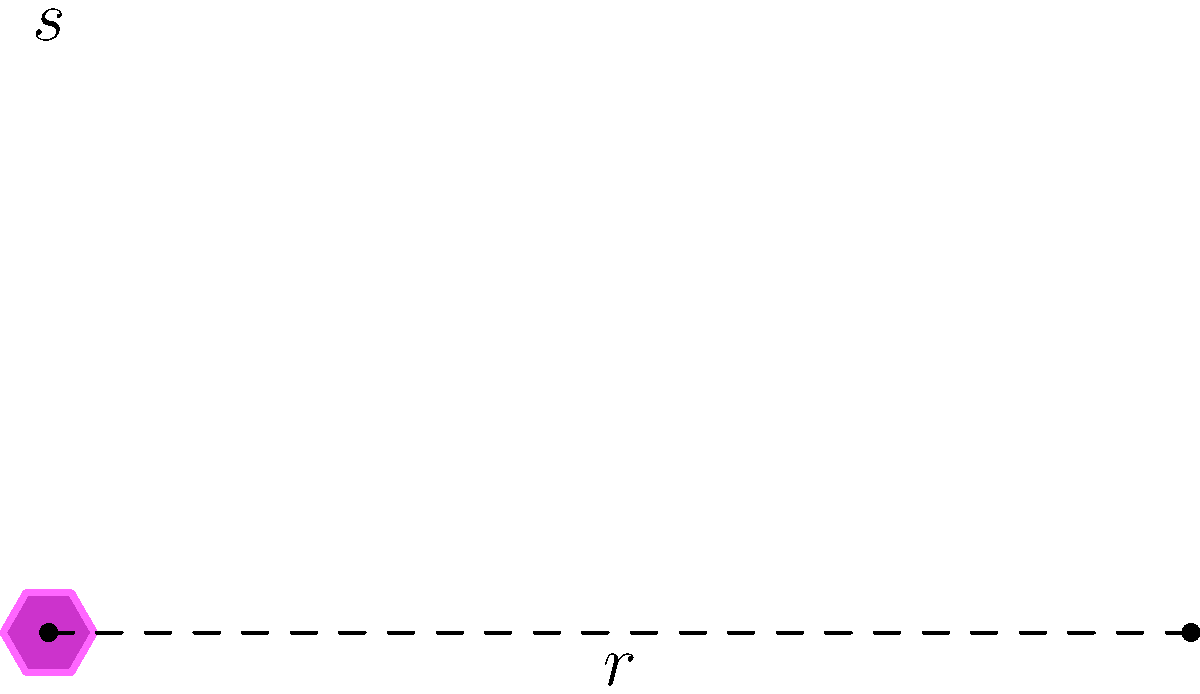At the Starlight Arcade, you're setting up a retro-themed Jem and the Holograms game inside a hexagonal cabinet. The cabinet's base forms a regular hexagon with side length $s = 2.5$ feet. Calculate the floor space area the cabinet occupies. Let's approach this step-by-step:

1) The area of a regular hexagon is given by the formula:

   $$A = \frac{3\sqrt{3}}{2}s^2$$

   where $s$ is the length of one side.

2) We're given that $s = 2.5$ feet.

3) Let's substitute this into our formula:

   $$A = \frac{3\sqrt{3}}{2}(2.5)^2$$

4) First, let's calculate $s^2$:
   
   $$(2.5)^2 = 6.25$$

5) Now our equation looks like this:

   $$A = \frac{3\sqrt{3}}{2}(6.25)$$

6) Let's multiply:

   $$A = 9.375\sqrt{3}$$

7) Using a calculator to approximate $\sqrt{3}$:

   $$A \approx 9.375 * 1.732 \approx 16.2375$$

8) Rounding to two decimal places:

   $$A \approx 16.24 \text{ square feet}$$

This retro arcade cabinet, reminiscent of the vibrant 80s aesthetic of Jem and the Holograms, occupies approximately 16.24 square feet of floor space.
Answer: 16.24 sq ft 